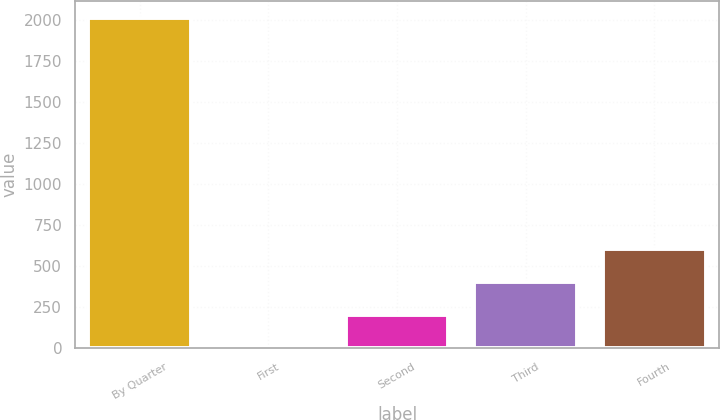Convert chart. <chart><loc_0><loc_0><loc_500><loc_500><bar_chart><fcel>By Quarter<fcel>First<fcel>Second<fcel>Third<fcel>Fourth<nl><fcel>2016<fcel>0.66<fcel>202.19<fcel>403.72<fcel>605.25<nl></chart> 